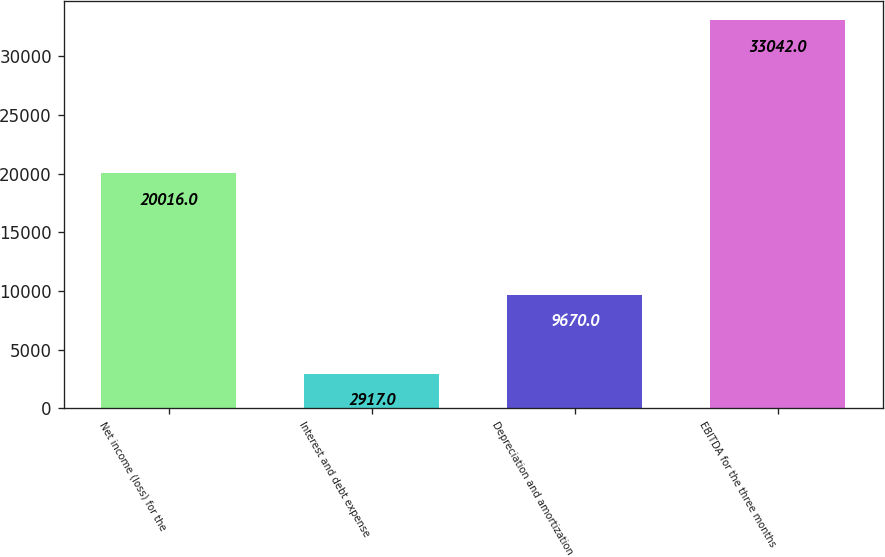<chart> <loc_0><loc_0><loc_500><loc_500><bar_chart><fcel>Net income (loss) for the<fcel>Interest and debt expense<fcel>Depreciation and amortization<fcel>EBITDA for the three months<nl><fcel>20016<fcel>2917<fcel>9670<fcel>33042<nl></chart> 